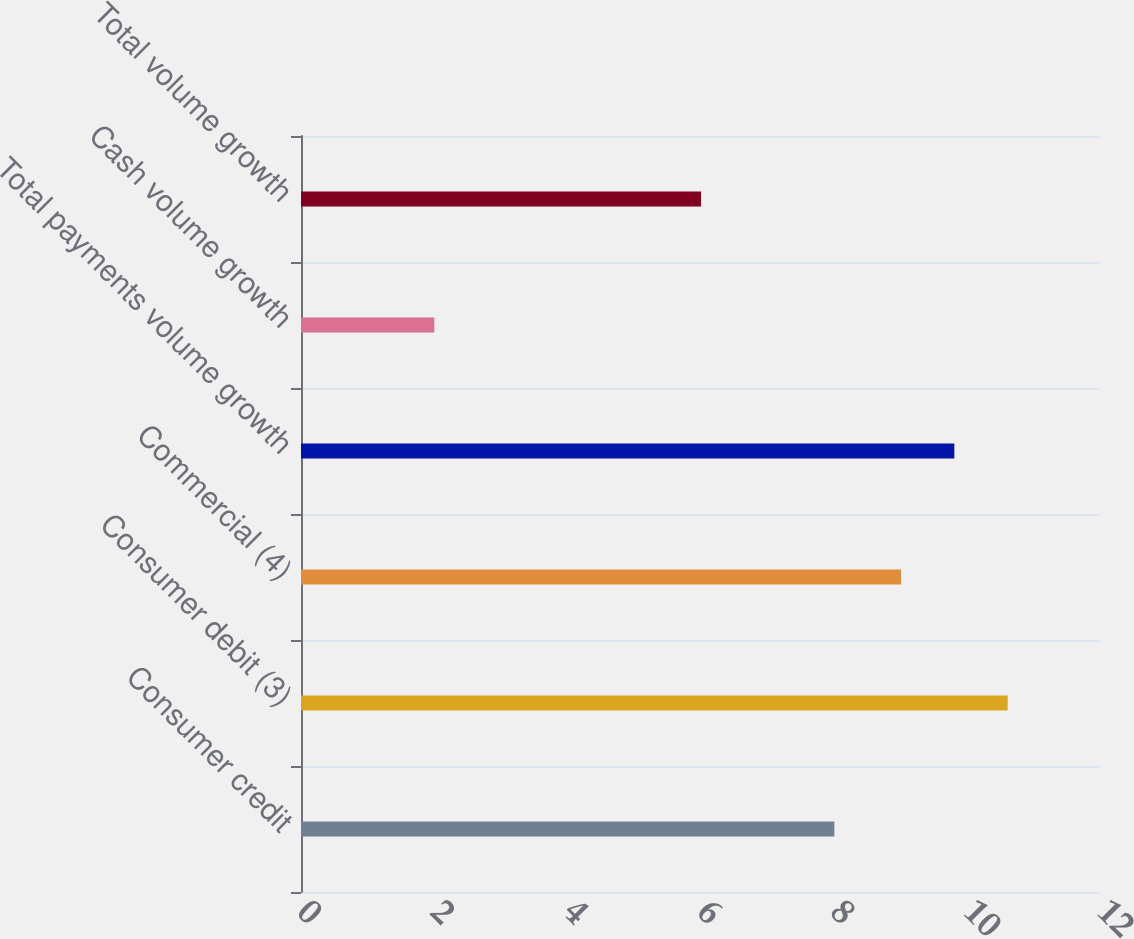Convert chart. <chart><loc_0><loc_0><loc_500><loc_500><bar_chart><fcel>Consumer credit<fcel>Consumer debit (3)<fcel>Commercial (4)<fcel>Total payments volume growth<fcel>Cash volume growth<fcel>Total volume growth<nl><fcel>8<fcel>10.6<fcel>9<fcel>9.8<fcel>2<fcel>6<nl></chart> 